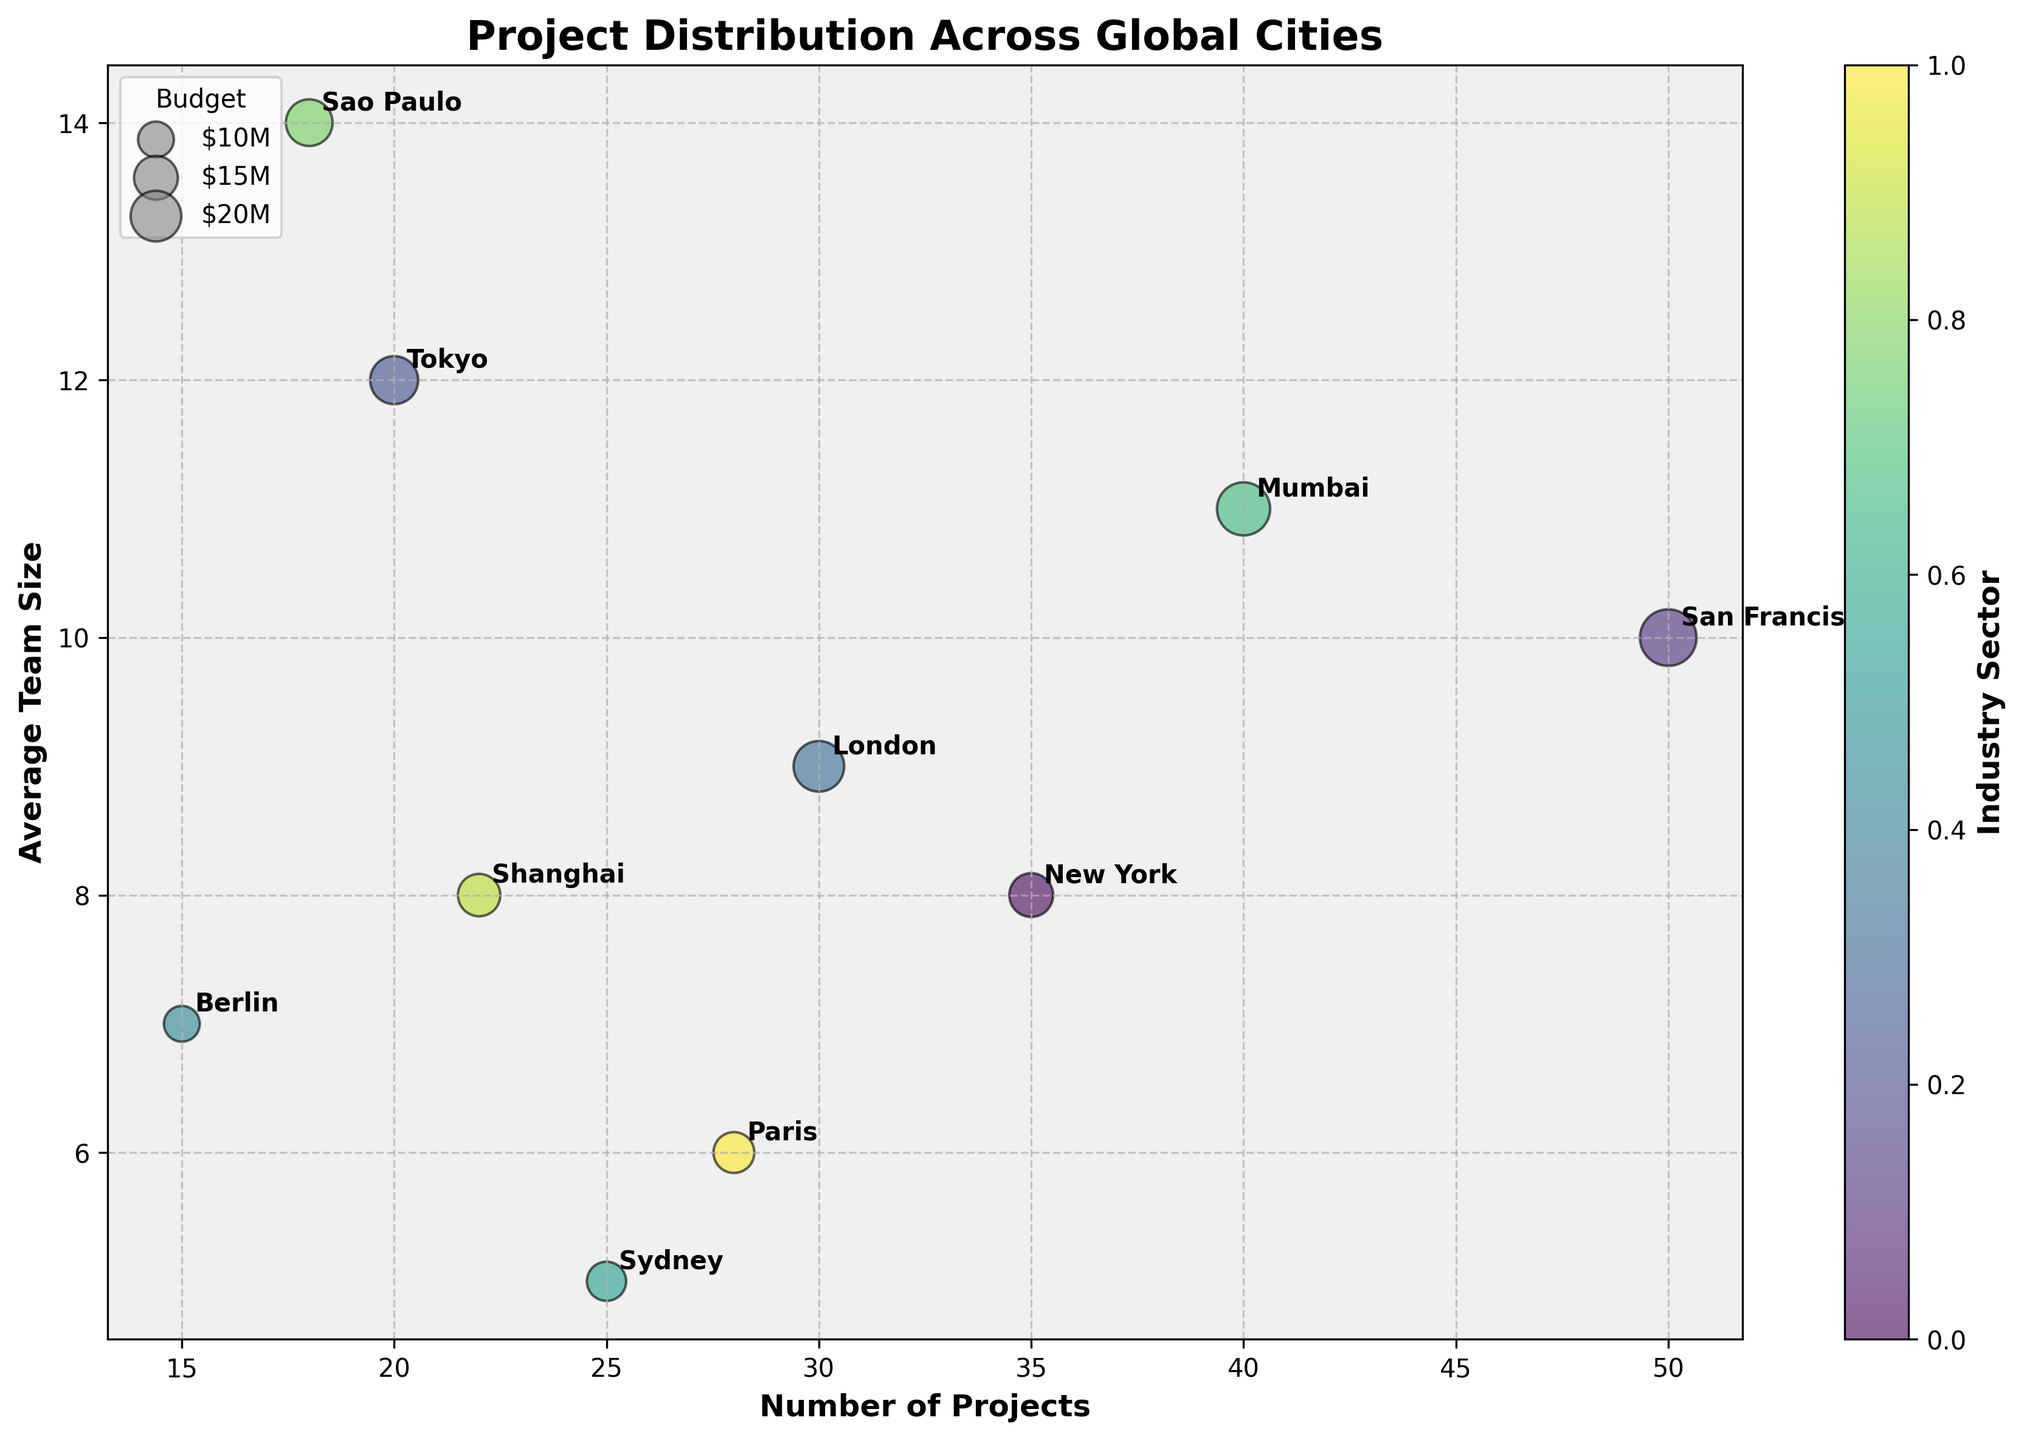What's the title of the chart? The title of the chart is written at the top of the figure and indicates what the chart is about.
Answer: Project Distribution Across Global Cities Which city has the highest number of projects? By looking at the X-axis (Number of Projects) and identifying the city positioned furthest to the right, we see that San Francisco has the highest number of projects.
Answer: San Francisco What is the average team size in Mumbai? By finding Mumbai on the chart and looking at the Y-axis (Average Team Size), we can see that the average team size is indicated there.
Answer: 11 Which industries have budgets represented by the largest bubbles, and in which cities are these located? Larger bubbles indicate higher budgets. By examining the figure for the largest bubbles, we see they represent the Technology sector in San Francisco and the Telecommunication sector in Mumbai.
Answer: Technology in San Francisco and Telecommunication in Mumbai How many cities have a number of projects greater than 20 but less than 40? By looking at the X-axis (Number of Projects) and finding markers between 20 and 40, we count the cities within this range: New York, London, Sydney, Shanghai, and Paris.
Answer: 5 What is the budget for the city with the smallest average team size? Finding the city with the smallest Y-axis value (Average Team Size), we see it is Sydney. We then look at the bubble size which corresponds to a budget of $12 Million USD.
Answer: $12 Million USD Which city has the highest average team size and how many projects does this city have? Looking for the highest Y-axis value, we find that Sao Paulo has the highest average team size. From the X-axis, Sao Paulo has 18 projects.
Answer: Sao Paulo with 18 projects Compare the budgets of New York and London. Which one is larger and by how much? Finding the bubble sizes for New York and London, we convert sizes to budgets. New York has $15 Million USD, and London has $20 Million USD; thus, London’s budget is larger by $5 Million USD.
Answer: London by $5 Million USD Which city represents the Healthcare sector, and what is its number of projects and average team size? By examining the cities and their sectors visible in the annotations, we find London in the Healthcare sector, having 30 projects (X-axis) and an average team size of 9 (Y-axis).
Answer: London, 30 projects, 9 average team size What is the difference in average team size between Tokyo and San Francisco? Finding the Y-axis values for Tokyo (12) and San Francisco (10), we subtract the latter from the former to get the difference.
Answer: 2 